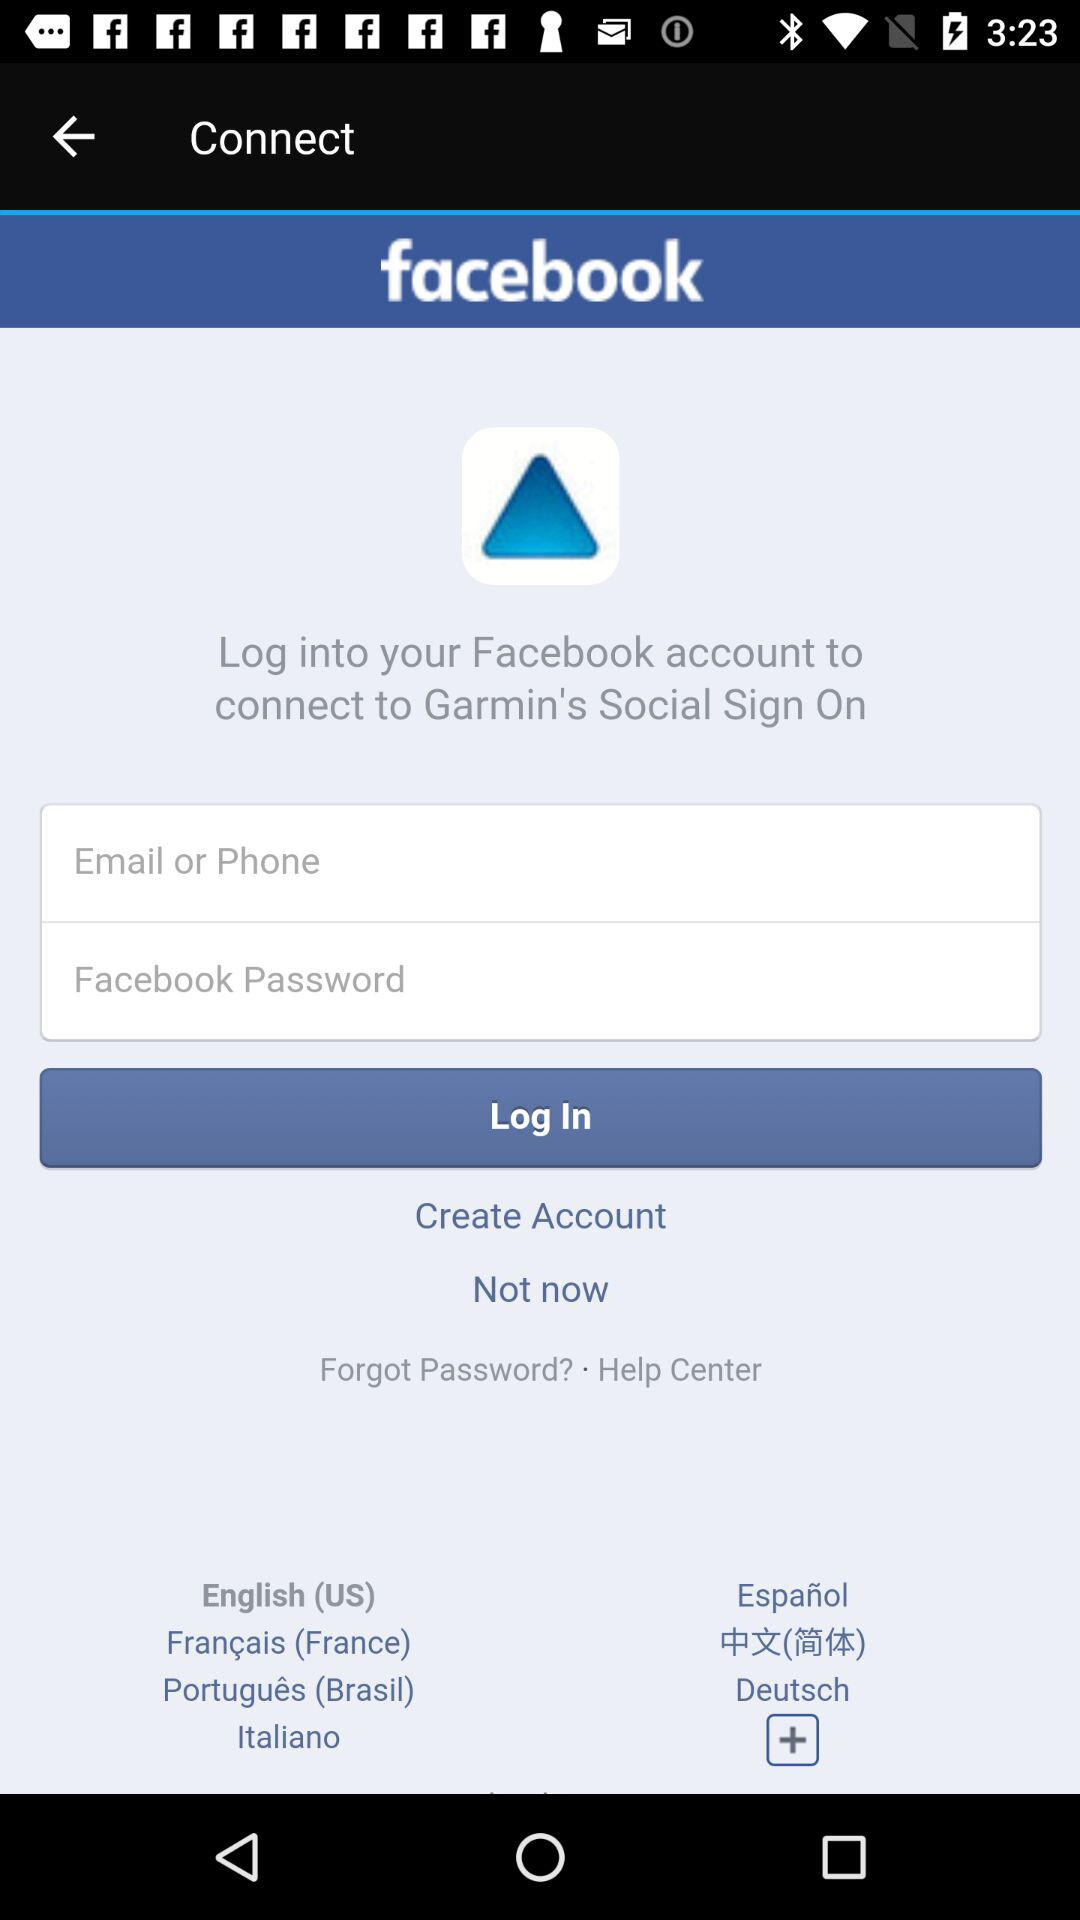How many languages are available for selection?
Answer the question using a single word or phrase. 7 